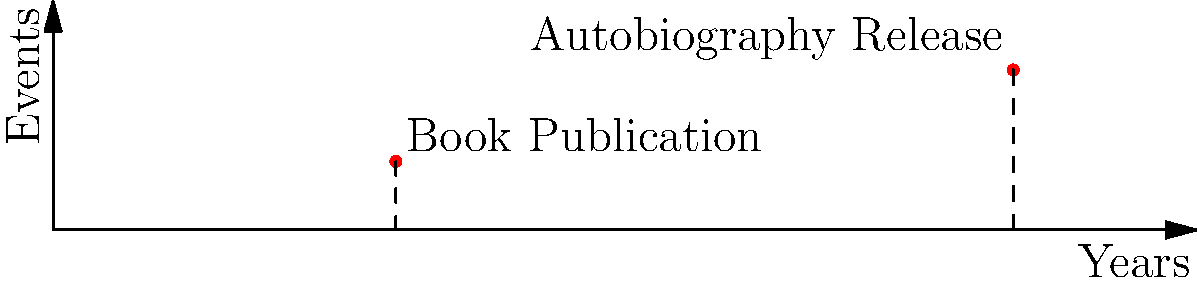On a timeline of your life events, your first book publication occurred at year 15, while your critically acclaimed autobiography was released at year 42. Using the coordinate plane where the x-axis represents years and the y-axis represents significant events, calculate the distance between these two pivotal moments in your writing career. Round your answer to two decimal places. To find the distance between two points on a coordinate plane, we can use the distance formula:

$$d = \sqrt{(x_2 - x_1)^2 + (y_2 - y_1)^2}$$

Where $(x_1, y_1)$ is the first point and $(x_2, y_2)$ is the second point.

Given:
- Book Publication: (15, 3)
- Autobiography Release: (42, 7)

Let's plug these values into the formula:

$$\begin{align}
d &= \sqrt{(42 - 15)^2 + (7 - 3)^2} \\
&= \sqrt{27^2 + 4^2} \\
&= \sqrt{729 + 16} \\
&= \sqrt{745} \\
&\approx 27.29
\end{align}$$

Rounding to two decimal places, we get 27.29.
Answer: 27.29 